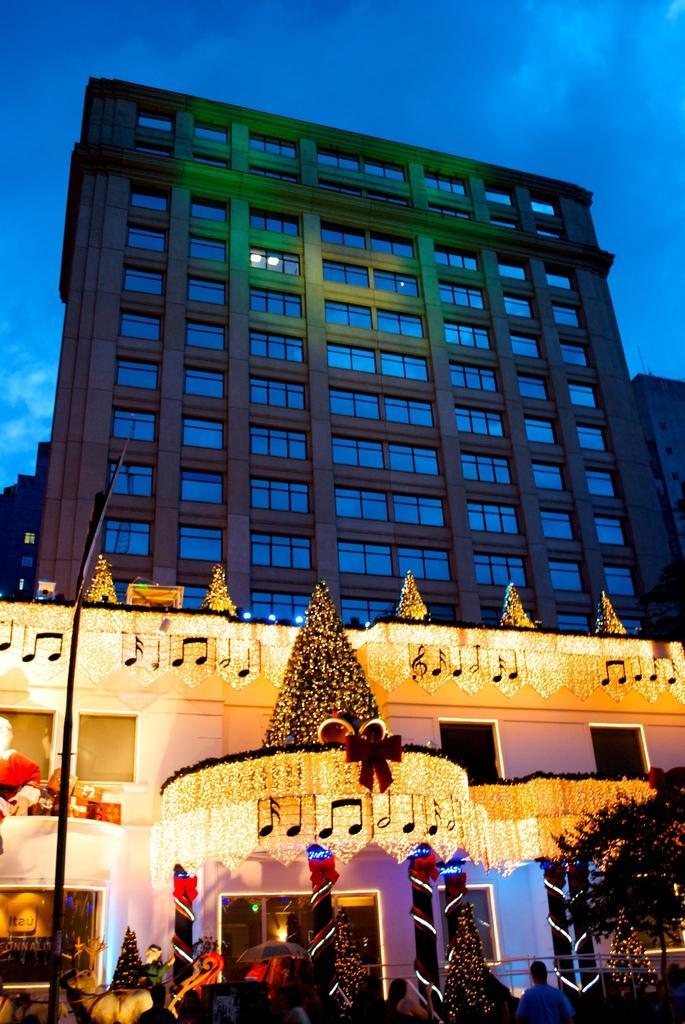Can you describe this image briefly? In front of the picture, we see a building which is decorated with lights. Behind that, we see buildings. At the bottom of the picture, we see people standing. We see trees decorated with lights. In the right bottom of the picture, we see a tree and in the left bottom of the picture, we see a pole. At the top of the picture, we see the sky, which is blue in color. 